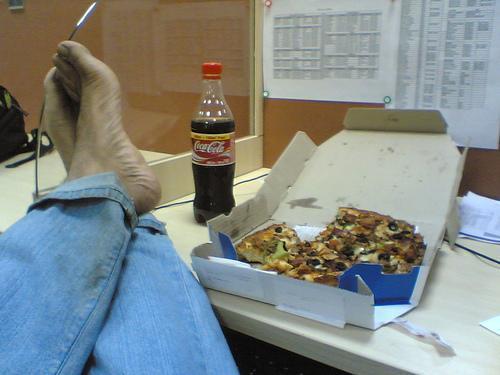What are the black things on the person's food?
Select the accurate response from the four choices given to answer the question.
Options: Pepperonis, black olives, sausage, peppers. Black olives. 